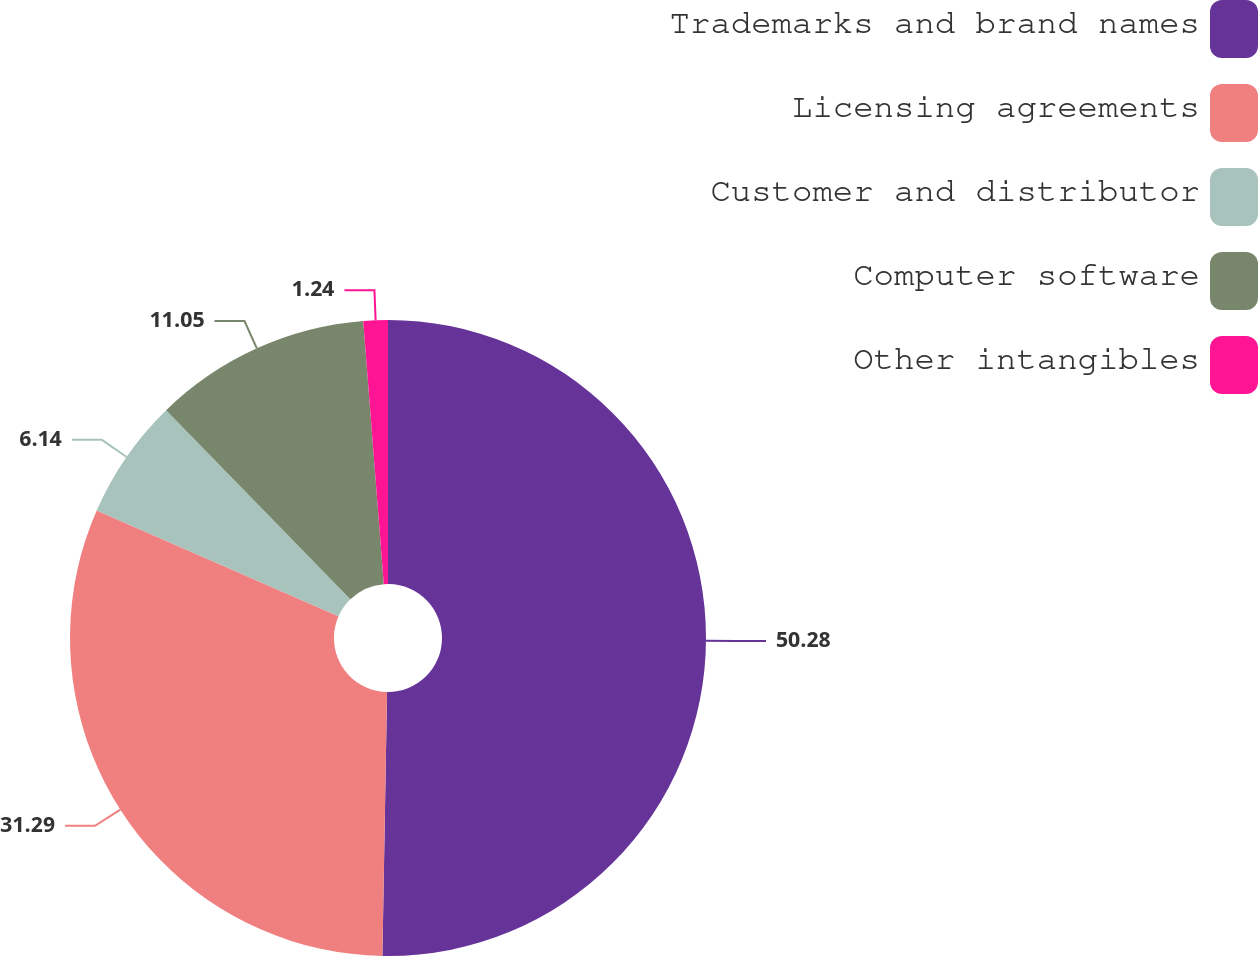Convert chart. <chart><loc_0><loc_0><loc_500><loc_500><pie_chart><fcel>Trademarks and brand names<fcel>Licensing agreements<fcel>Customer and distributor<fcel>Computer software<fcel>Other intangibles<nl><fcel>50.28%<fcel>31.29%<fcel>6.14%<fcel>11.05%<fcel>1.24%<nl></chart> 